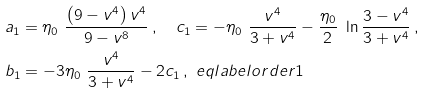Convert formula to latex. <formula><loc_0><loc_0><loc_500><loc_500>& a _ { 1 } = \eta _ { 0 } \ \frac { \left ( 9 - v ^ { 4 } \right ) v ^ { 4 } } { 9 - v ^ { 8 } } \, , \quad c _ { 1 } = - \eta _ { 0 } \ \frac { v ^ { 4 } } { 3 + v ^ { 4 } } - \frac { \eta _ { 0 } } { 2 } \ \ln \frac { 3 - v ^ { 4 } } { 3 + v ^ { 4 } } \, , \\ & b _ { 1 } = - 3 \eta _ { 0 } \ \frac { v ^ { 4 } } { 3 + v ^ { 4 } } - 2 c _ { 1 } \, , \ e q l a b e l { o r d e r 1 }</formula> 